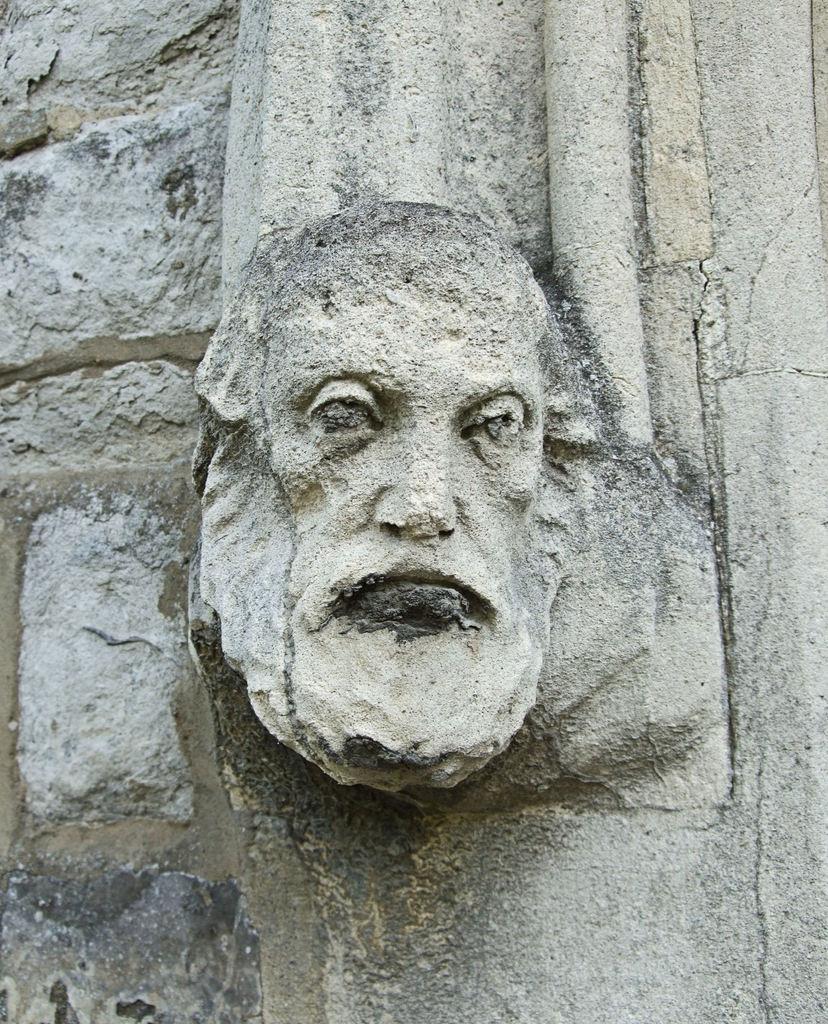Please provide a concise description of this image. We can see stone carving of a human face on a wall. 